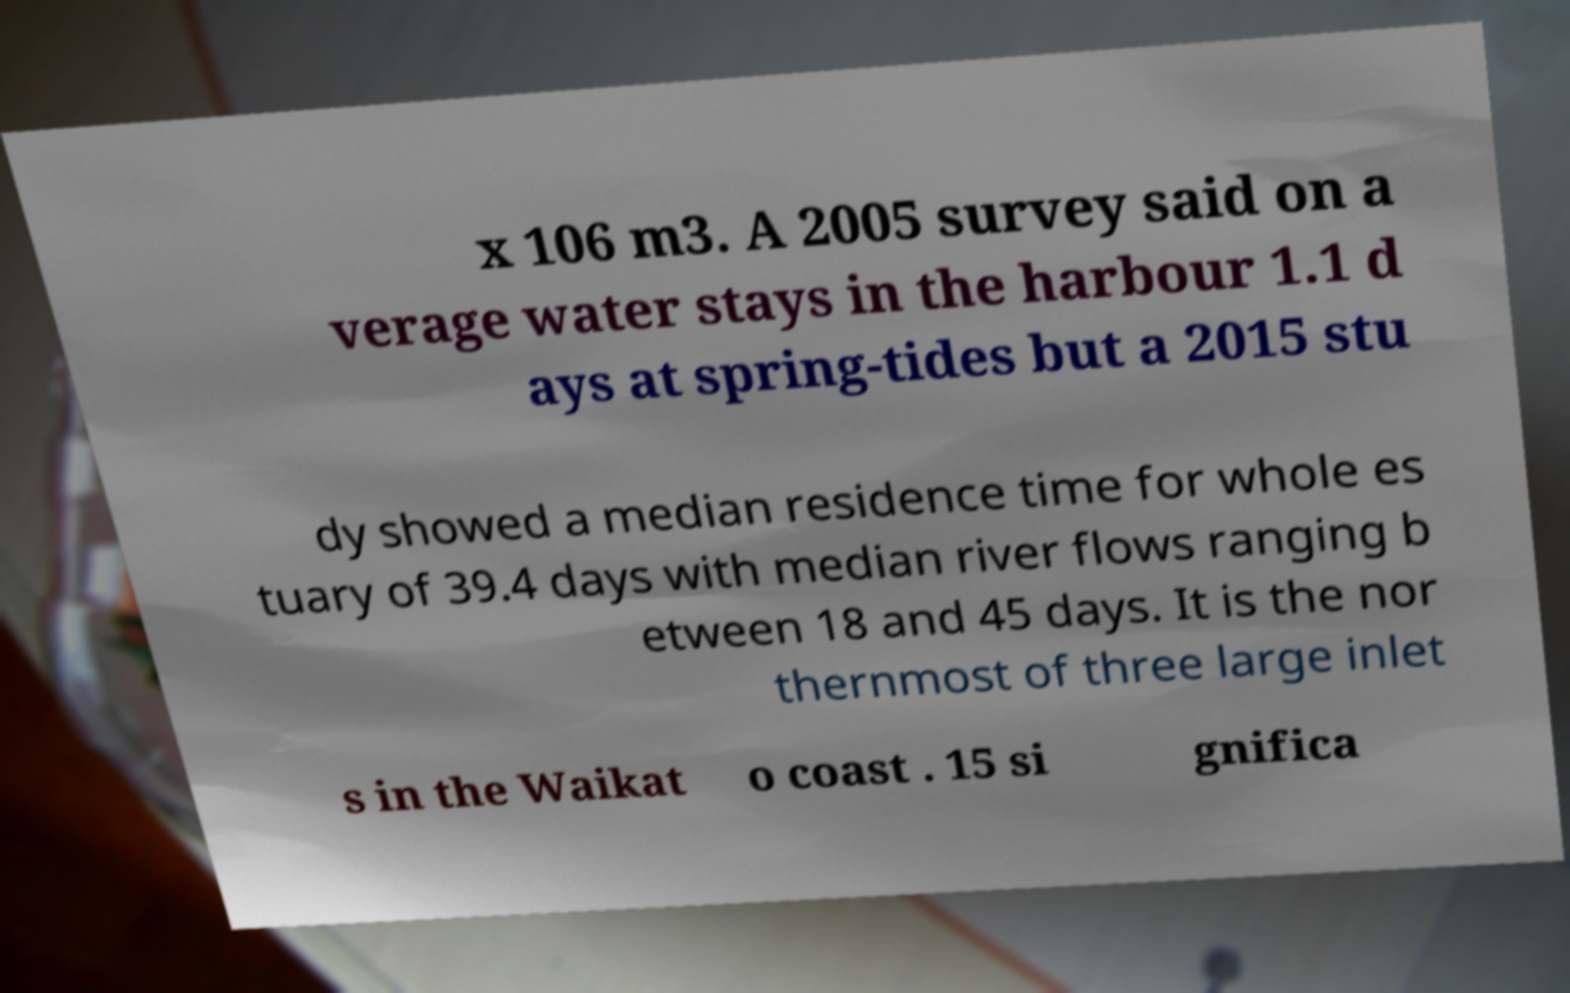Can you read and provide the text displayed in the image?This photo seems to have some interesting text. Can you extract and type it out for me? x 106 m3. A 2005 survey said on a verage water stays in the harbour 1.1 d ays at spring-tides but a 2015 stu dy showed a median residence time for whole es tuary of 39.4 days with median river flows ranging b etween 18 and 45 days. It is the nor thernmost of three large inlet s in the Waikat o coast . 15 si gnifica 